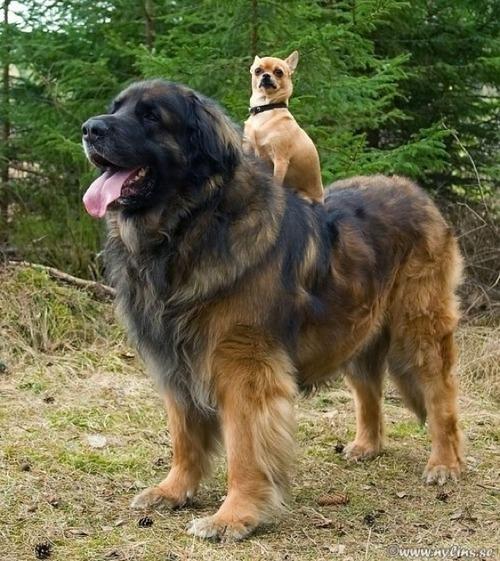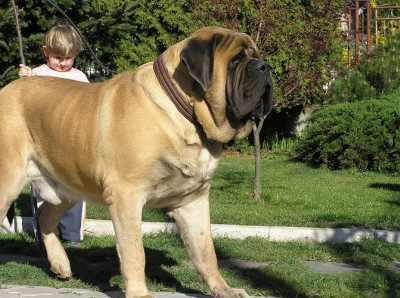The first image is the image on the left, the second image is the image on the right. Considering the images on both sides, is "There is a small child playing with a big dog." valid? Answer yes or no. Yes. 